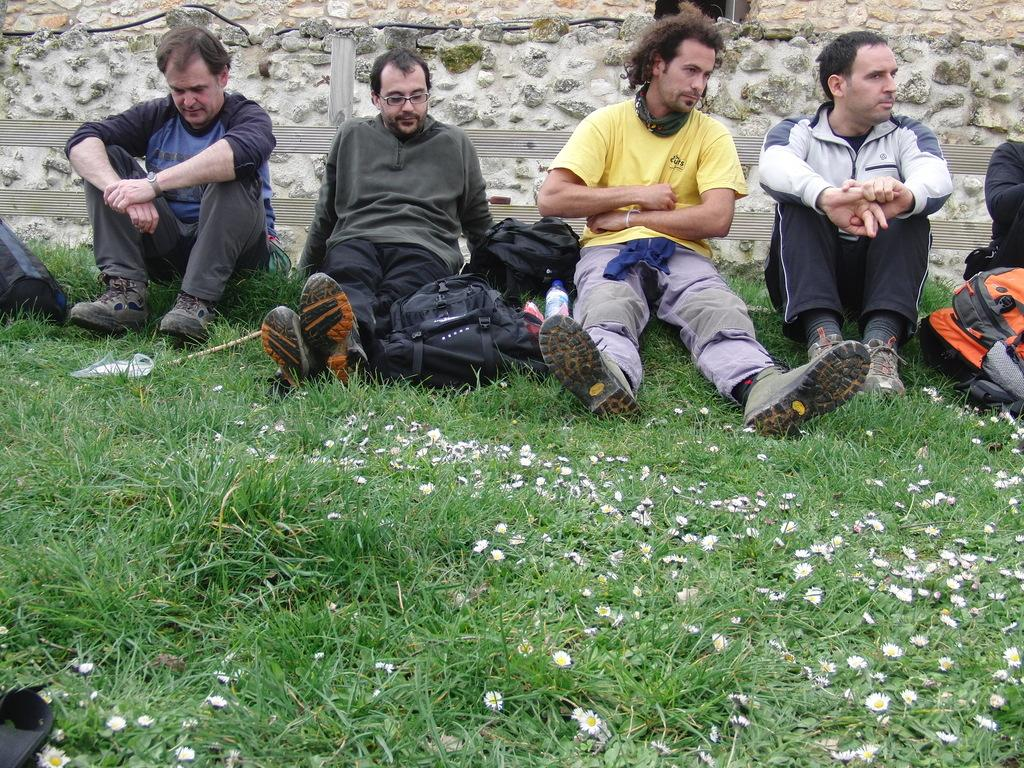What are the people in the image doing? The people in the image are sitting on the grass. What can be seen besides the people in the image? There are bags and flowers visible in the image, as well as other objects. What is visible in the background of the image? There is a fence and a wall in the background of the image. What type of yoke can be seen in the image? There is no yoke present in the image. Can you identify the animal that is grazing in the background of the image? There are no animals visible in the image; it only features people, bags, flowers, and other objects. 